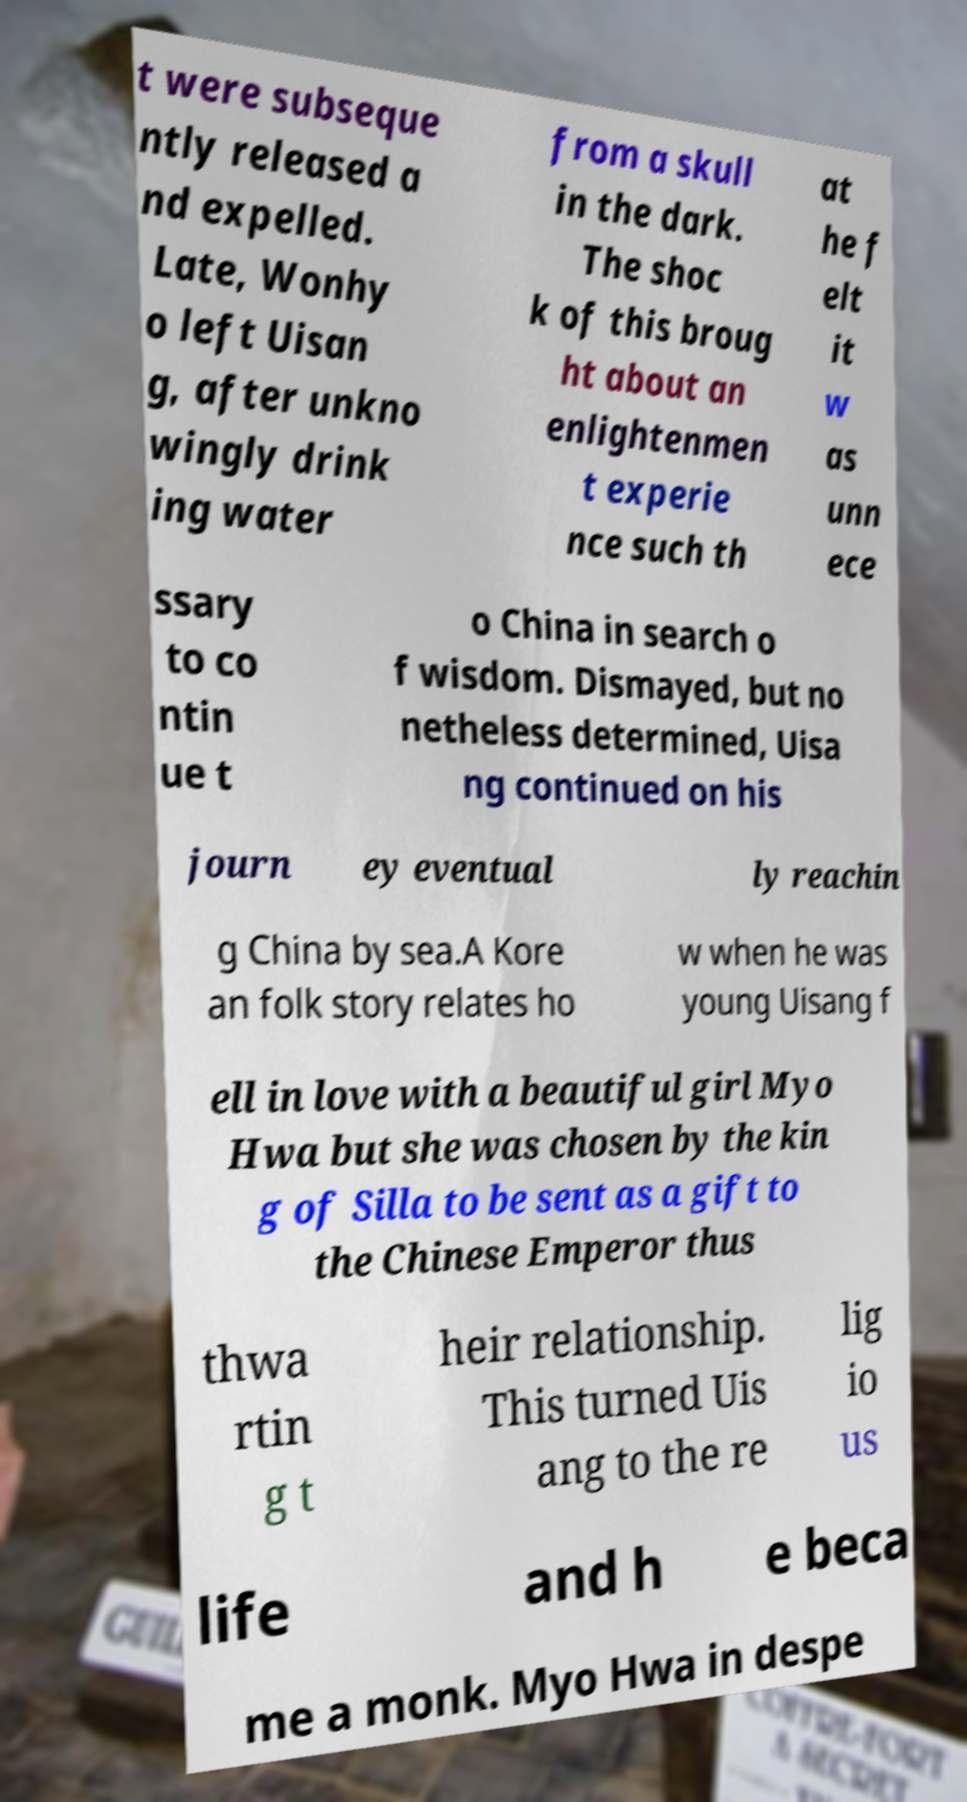Can you read and provide the text displayed in the image?This photo seems to have some interesting text. Can you extract and type it out for me? t were subseque ntly released a nd expelled. Late, Wonhy o left Uisan g, after unkno wingly drink ing water from a skull in the dark. The shoc k of this broug ht about an enlightenmen t experie nce such th at he f elt it w as unn ece ssary to co ntin ue t o China in search o f wisdom. Dismayed, but no netheless determined, Uisa ng continued on his journ ey eventual ly reachin g China by sea.A Kore an folk story relates ho w when he was young Uisang f ell in love with a beautiful girl Myo Hwa but she was chosen by the kin g of Silla to be sent as a gift to the Chinese Emperor thus thwa rtin g t heir relationship. This turned Uis ang to the re lig io us life and h e beca me a monk. Myo Hwa in despe 